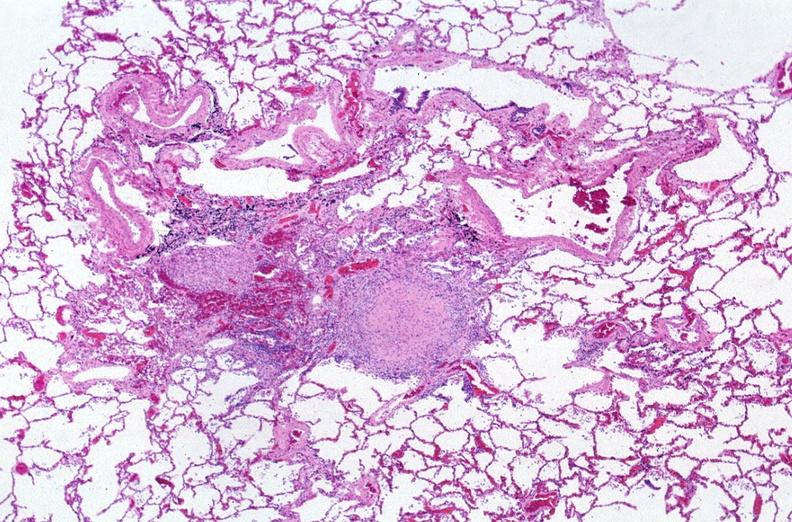s so-called median bar present?
Answer the question using a single word or phrase. No 